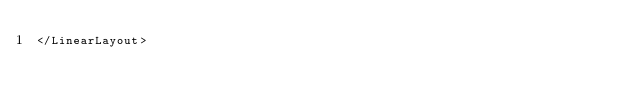Convert code to text. <code><loc_0><loc_0><loc_500><loc_500><_XML_></LinearLayout>
</code> 